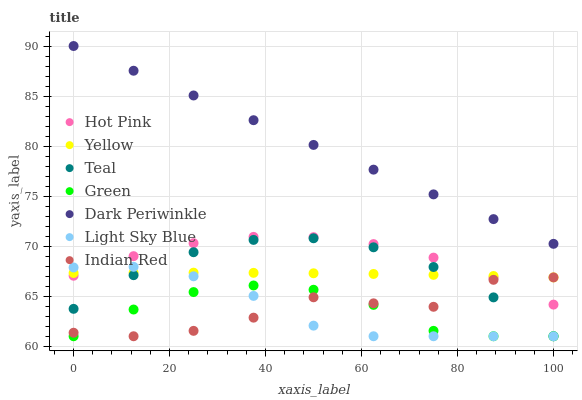Does Green have the minimum area under the curve?
Answer yes or no. Yes. Does Dark Periwinkle have the maximum area under the curve?
Answer yes or no. Yes. Does Hot Pink have the minimum area under the curve?
Answer yes or no. No. Does Hot Pink have the maximum area under the curve?
Answer yes or no. No. Is Dark Periwinkle the smoothest?
Answer yes or no. Yes. Is Indian Red the roughest?
Answer yes or no. Yes. Is Hot Pink the smoothest?
Answer yes or no. No. Is Hot Pink the roughest?
Answer yes or no. No. Does Indian Red have the lowest value?
Answer yes or no. Yes. Does Hot Pink have the lowest value?
Answer yes or no. No. Does Dark Periwinkle have the highest value?
Answer yes or no. Yes. Does Hot Pink have the highest value?
Answer yes or no. No. Is Teal less than Hot Pink?
Answer yes or no. Yes. Is Dark Periwinkle greater than Green?
Answer yes or no. Yes. Does Light Sky Blue intersect Indian Red?
Answer yes or no. Yes. Is Light Sky Blue less than Indian Red?
Answer yes or no. No. Is Light Sky Blue greater than Indian Red?
Answer yes or no. No. Does Teal intersect Hot Pink?
Answer yes or no. No. 